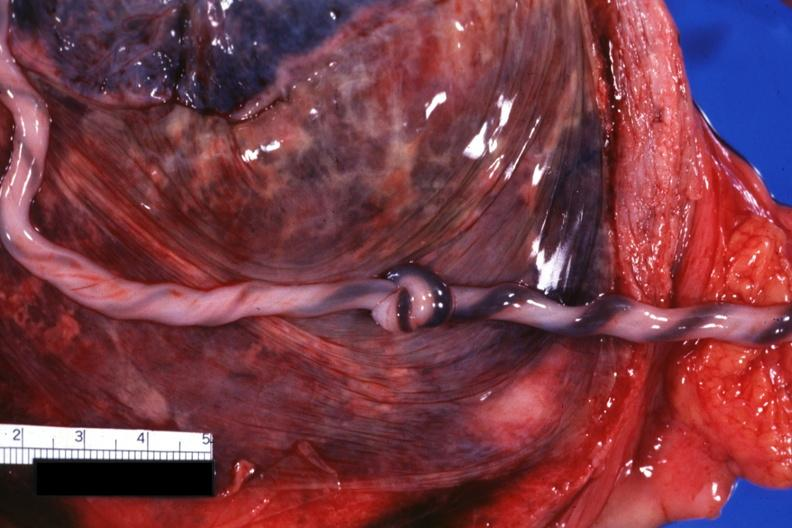s muscle atrophy present?
Answer the question using a single word or phrase. No 